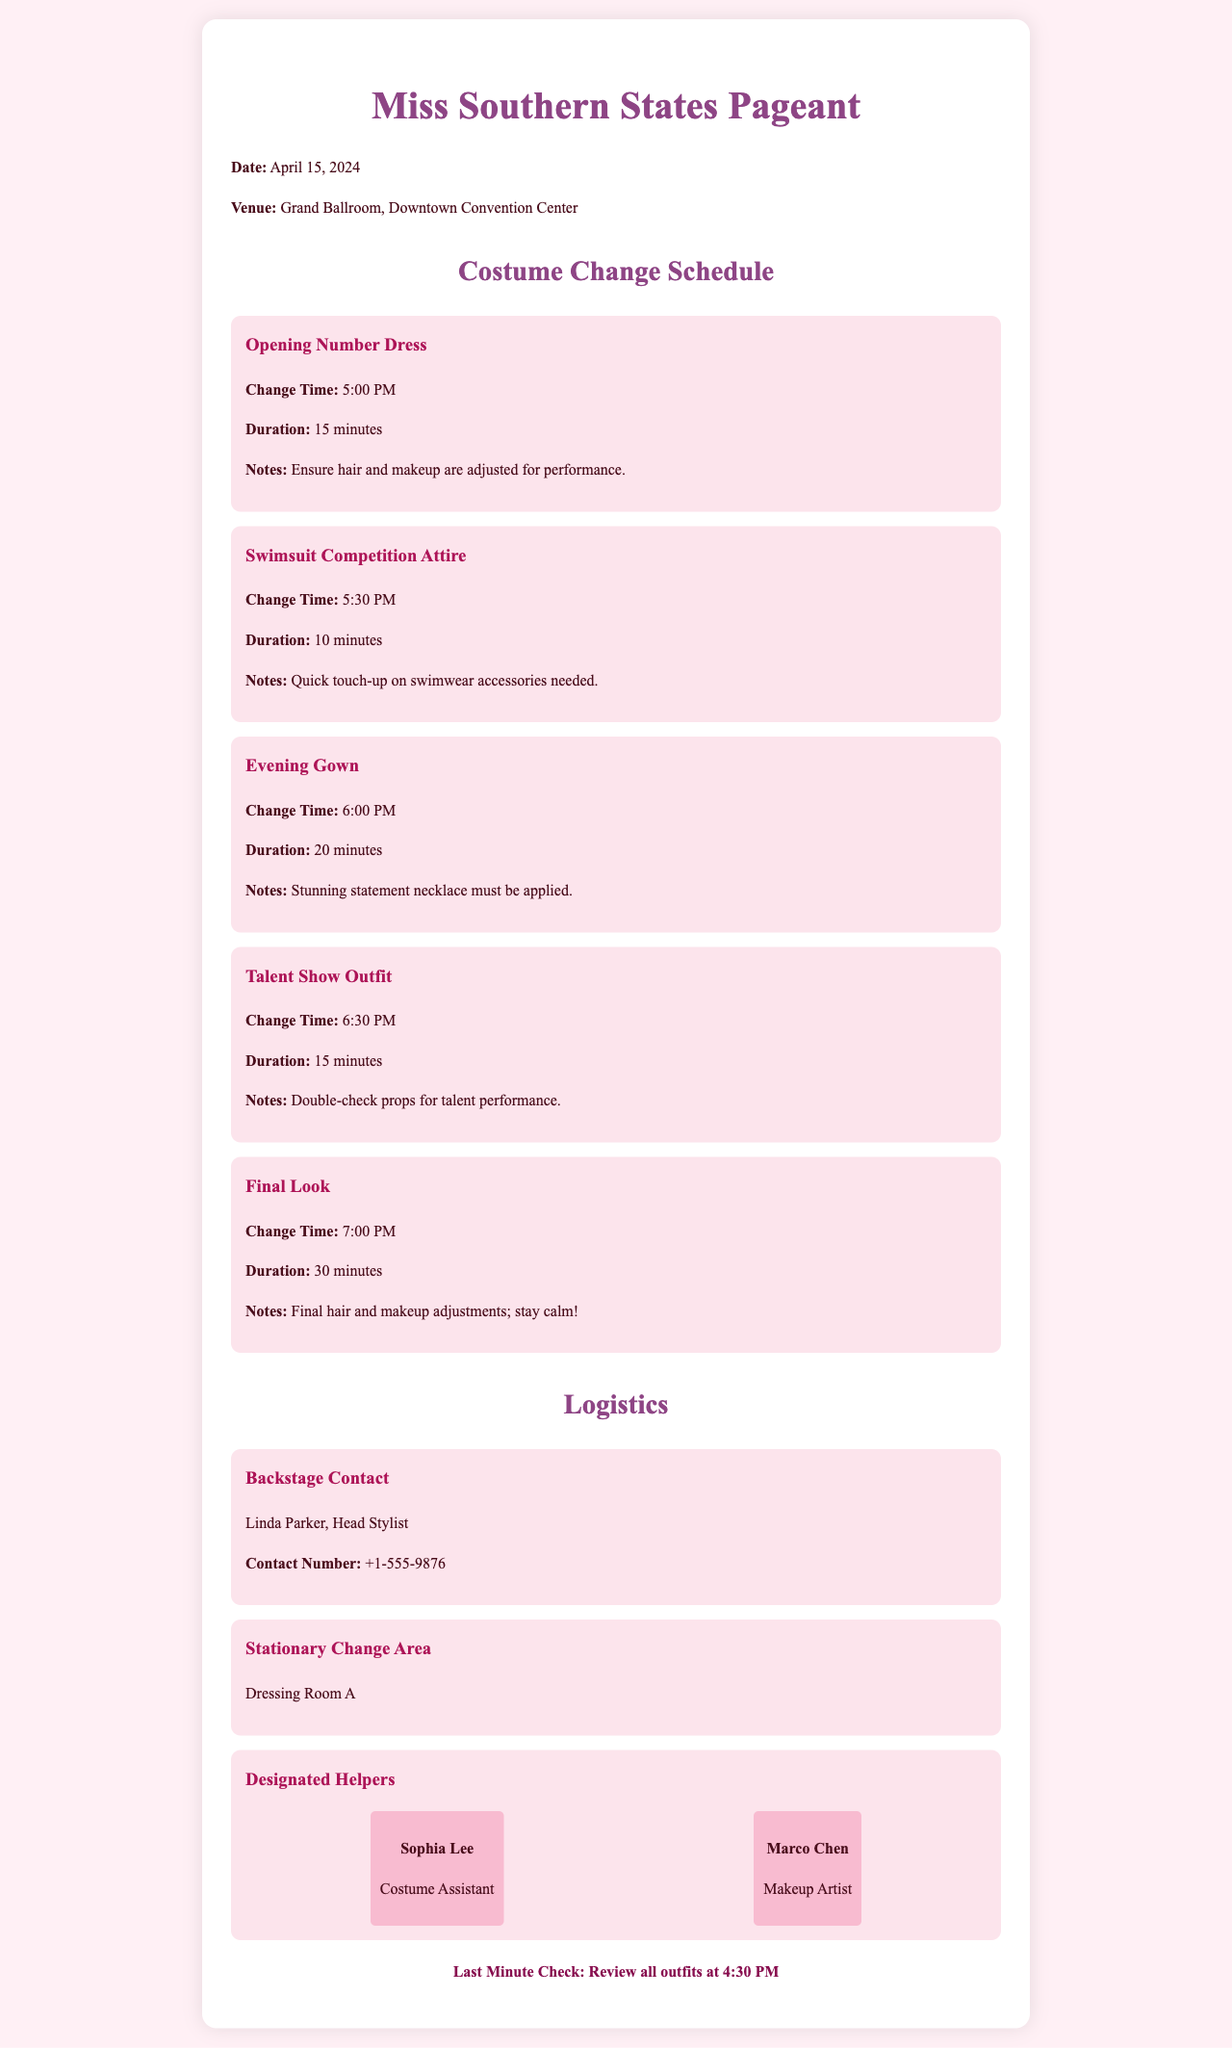What is the date of the pageant? The date of the pageant is stated at the beginning of the document.
Answer: April 15, 2024 What is the venue for the pageant? The venue is mentioned alongside the date, providing the location details.
Answer: Grand Ballroom, Downtown Convention Center What time is the costume change for the Evening Gown? The specific time for the Evening Gown change is listed in the schedule section.
Answer: 6:00 PM How long is the change duration for the Final Look? The duration for the Final Look change is indicated in the schedule.
Answer: 30 minutes Who is the Head Stylist backstage? The Head Stylist's name is provided in the logistics section.
Answer: Linda Parker Where is the stationary change area located? The location of the stationary change area is mentioned in the logistics section.
Answer: Dressing Room A What should be double-checked for the Talent Show Outfit? The notes section for the Talent Show Outfit specifies what needs to be checked.
Answer: Props What time should the last minute check be conducted? The time for the last minute check is stated towards the end of the document.
Answer: 4:30 PM What is the first costume change noted? The first costume in the change schedule is indicated.
Answer: Opening Number Dress 